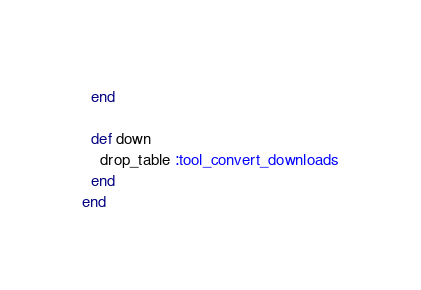<code> <loc_0><loc_0><loc_500><loc_500><_Ruby_>  end

  def down
    drop_table :tool_convert_downloads
  end
end
</code> 